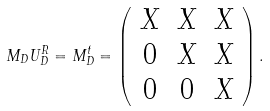Convert formula to latex. <formula><loc_0><loc_0><loc_500><loc_500>M _ { D } U _ { D } ^ { R } = M _ { D } ^ { t } = \left ( \begin{array} { c c c } X & X & X \\ 0 & X & X \\ 0 & 0 & X \\ \end{array} \right ) .</formula> 